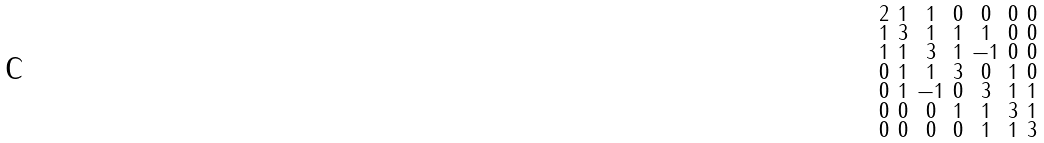Convert formula to latex. <formula><loc_0><loc_0><loc_500><loc_500>\begin{smallmatrix} 2 & 1 & 1 & 0 & 0 & 0 & 0 \\ 1 & 3 & 1 & 1 & 1 & 0 & 0 \\ 1 & 1 & 3 & 1 & - 1 & 0 & 0 \\ 0 & 1 & 1 & 3 & 0 & 1 & 0 \\ 0 & 1 & - 1 & 0 & 3 & 1 & 1 \\ 0 & 0 & 0 & 1 & 1 & 3 & 1 \\ 0 & 0 & 0 & 0 & 1 & 1 & 3 \end{smallmatrix}</formula> 